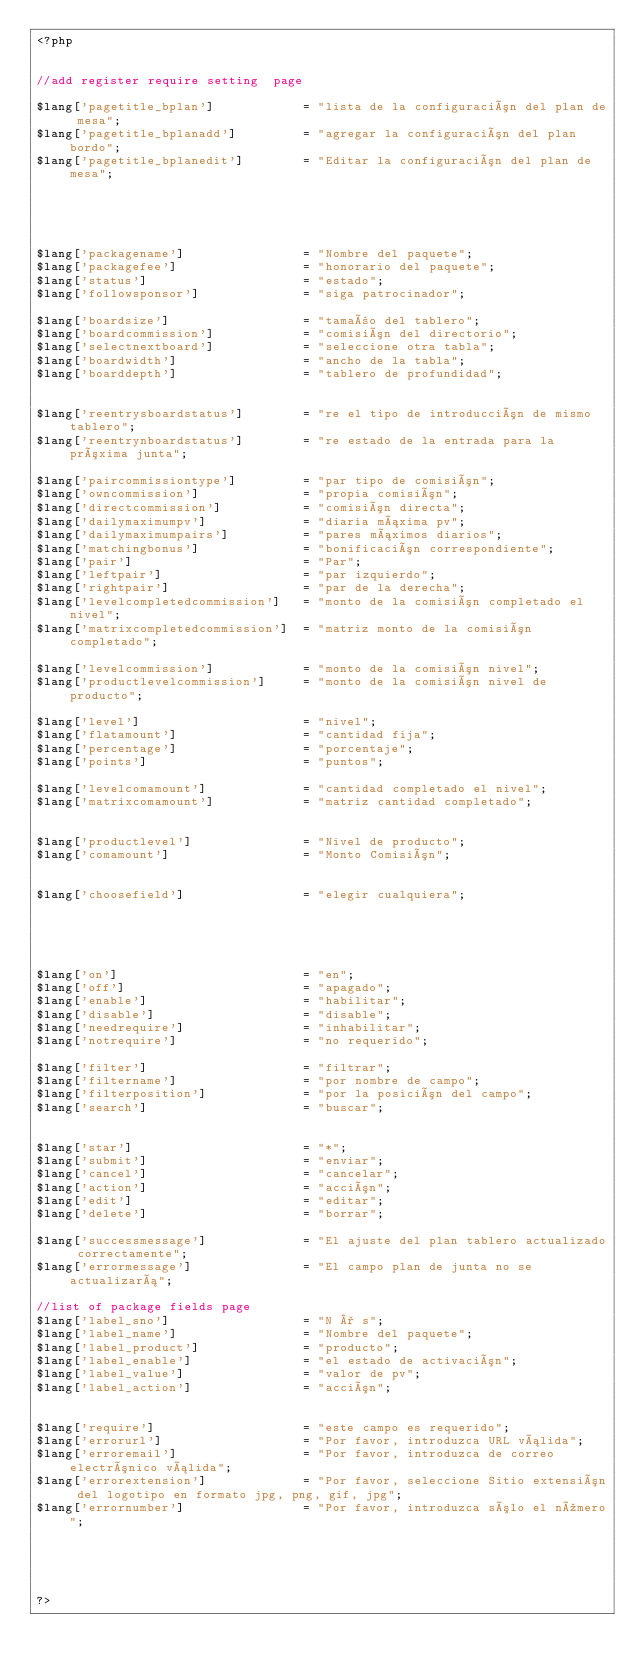<code> <loc_0><loc_0><loc_500><loc_500><_PHP_><?php 


//add register require setting  page

$lang['pagetitle_bplan'] 			= "lista de la configuración del plan de mesa";
$lang['pagetitle_bplanadd'] 		= "agregar la configuración del plan bordo";
$lang['pagetitle_bplanedit'] 		= "Editar la configuración del plan de mesa";





$lang['packagename'] 				= "Nombre del paquete";
$lang['packagefee'] 				= "honorario del paquete";
$lang['status'] 					= "estado";
$lang['followsponsor'] 				= "siga patrocinador";

$lang['boardsize'] 					= "tamaño del tablero";
$lang['boardcommission'] 			= "comisión del directorio";
$lang['selectnextboard'] 			= "seleccione otra tabla";
$lang['boardwidth'] 				= "ancho de la tabla";
$lang['boarddepth'] 				= "tablero de profundidad";


$lang['reentrysboardstatus'] 		= "re el tipo de introducción de mismo tablero";
$lang['reentrynboardstatus'] 		= "re estado de la entrada para la próxima junta";

$lang['paircommissiontype'] 		= "par tipo de comisión";
$lang['owncommission'] 				= "propia comisión";
$lang['directcommission'] 			= "comisión directa";
$lang['dailymaximumpv'] 			= "diaria máxima pv";
$lang['dailymaximumpairs'] 			= "pares máximos diarios";
$lang['matchingbonus'] 				= "bonificación correspondiente";
$lang['pair'] 						= "Par";
$lang['leftpair'] 					= "par izquierdo";
$lang['rightpair'] 					= "par de la derecha";
$lang['levelcompletedcommission'] 	= "monto de la comisión completado el nivel";
$lang['matrixcompletedcommission'] 	= "matriz monto de la comisión completado";

$lang['levelcommission'] 			= "monto de la comisión nivel";
$lang['productlevelcommission'] 	= "monto de la comisión nivel de producto";

$lang['level'] 						= "nivel";
$lang['flatamount'] 				= "cantidad fija";
$lang['percentage'] 				= "porcentaje";
$lang['points'] 					= "puntos";

$lang['levelcomamount'] 			= "cantidad completado el nivel";
$lang['matrixcomamount'] 			= "matriz cantidad completado";


$lang['productlevel'] 				= "Nivel de producto";
$lang['comamount'] 					= "Monto Comisión";


$lang['choosefield'] 				= "elegir cualquiera";





$lang['on'] 						= "en";
$lang['off'] 						= "apagado";
$lang['enable'] 					= "habilitar";
$lang['disable'] 					= "disable";
$lang['needrequire'] 				= "inhabilitar";
$lang['notrequire'] 				= "no requerido";

$lang['filter'] 					= "filtrar";
$lang['filtername'] 				= "por nombre de campo";
$lang['filterposition'] 			= "por la posición del campo";
$lang['search'] 					= "buscar";


$lang['star'] 						= "*";
$lang['submit'] 					= "enviar";
$lang['cancel'] 					= "cancelar";
$lang['action'] 					= "acción";
$lang['edit'] 						= "editar";
$lang['delete'] 					= "borrar";

$lang['successmessage'] 			= "El ajuste del plan tablero actualizado correctamente";
$lang['errormessage'] 				= "El campo plan de junta no se actualizará";

//list of package fields page
$lang['label_sno'] 					= "N ° s";
$lang['label_name'] 				= "Nombre del paquete";
$lang['label_product'] 				= "producto";
$lang['label_enable'] 				= "el estado de activación";
$lang['label_value'] 				= "valor de pv";
$lang['label_action'] 				= "acción";


$lang['require'] 					= "este campo es requerido";
$lang['errorurl'] 					= "Por favor, introduzca URL válida";
$lang['erroremail'] 				= "Por favor, introduzca de correo electrónico válida";
$lang['errorextension'] 			= "Por favor, seleccione Sitio extensión del logotipo en formato jpg, png, gif, jpg";
$lang['errornumber'] 				= "Por favor, introduzca sólo el número";





?></code> 